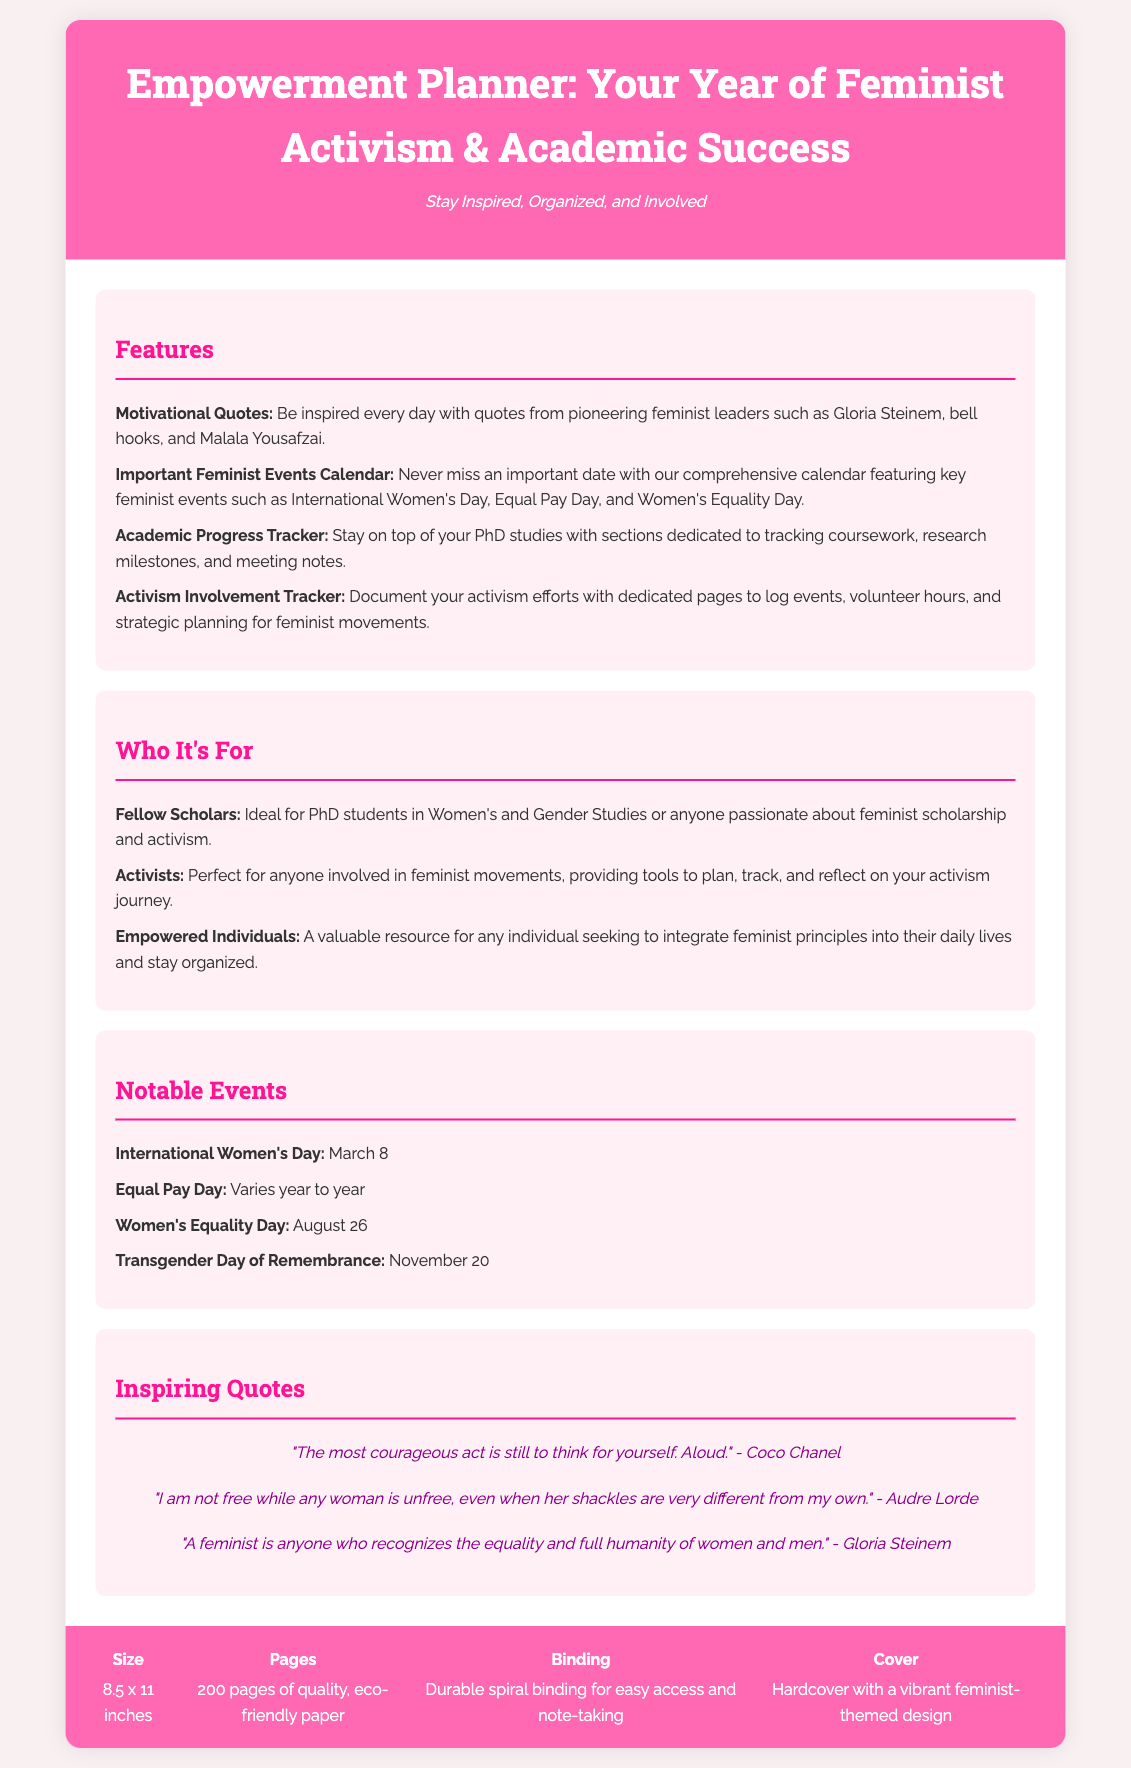what is the title of the planner? The title of the planner is prominently displayed in the document as "Empowerment Planner: Your Year of Feminist Activism & Academic Success."
Answer: Empowerment Planner: Your Year of Feminist Activism & Academic Success how many pages does the planner have? The number of pages is stated in the specifications section, where it mentions "200 pages of quality, eco-friendly paper."
Answer: 200 pages who is quoted in the planner? The document includes motivational quotes from pioneering feminist leaders, including names such as Gloria Steinem, bell hooks, and Malala Yousafzai, among others.
Answer: Gloria Steinem, bell hooks, Malala Yousafzai what significant date is marked on March 8? The calendar of important feminist events includes "International Women's Day" marked on March 8.
Answer: International Women's Day what type of binding does the planner have? The specifications indicate that the planner has "Durable spiral binding for easy access and note-taking."
Answer: Durable spiral binding which features help track academic progress? The section on features specifies an "Academic Progress Tracker" dedicated to tracking coursework, research milestones, and meeting notes.
Answer: Academic Progress Tracker who is the planner ideal for? The "Who It's For" section describes the planner as ideal for "Fellow Scholars," particularly PhD students in Women's and Gender Studies.
Answer: Fellow Scholars what is the cover design of the planner made from? The specifications section mentions that the cover features "a vibrant feminist-themed design."
Answer: vibrant feminist-themed design 